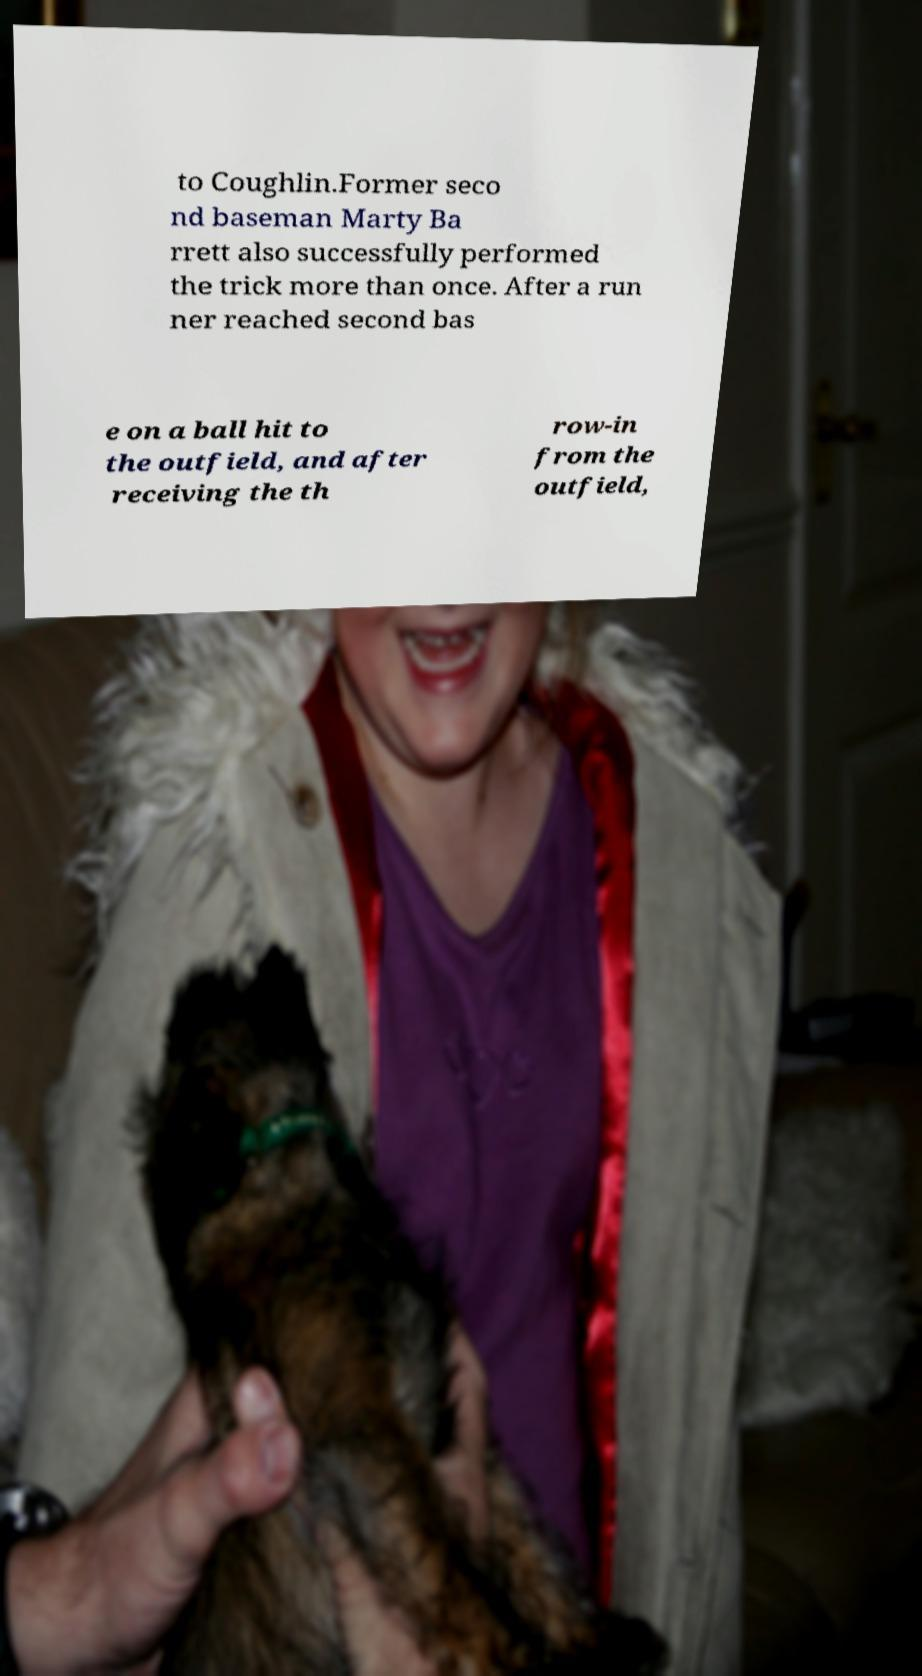I need the written content from this picture converted into text. Can you do that? to Coughlin.Former seco nd baseman Marty Ba rrett also successfully performed the trick more than once. After a run ner reached second bas e on a ball hit to the outfield, and after receiving the th row-in from the outfield, 